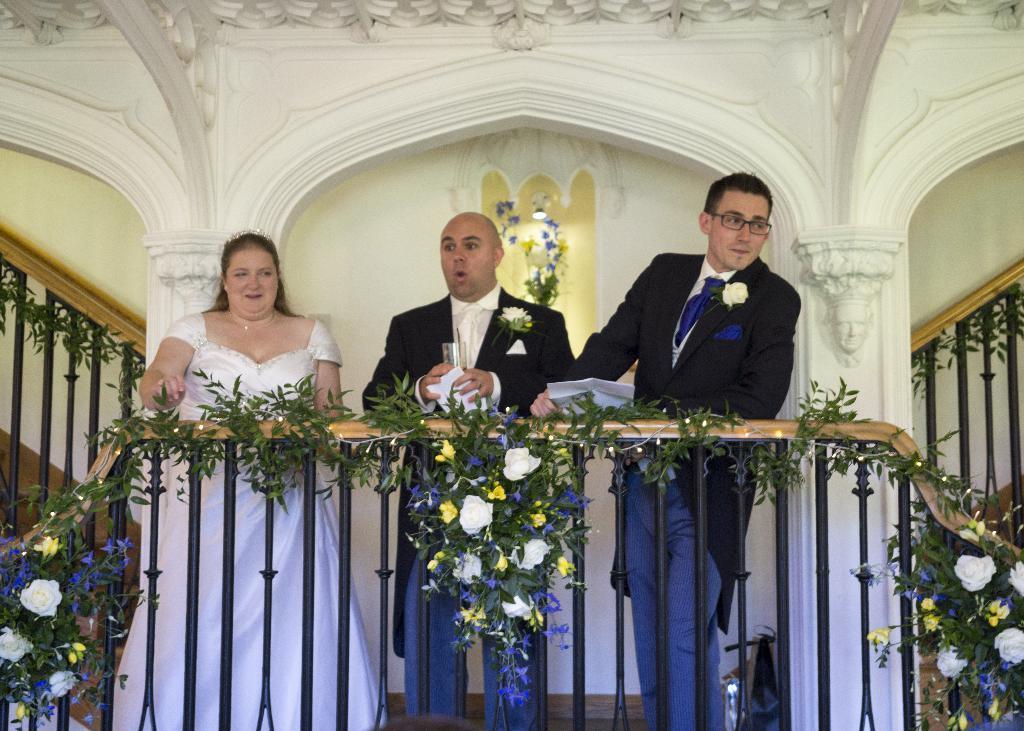Please provide a concise description of this image. In this picture, we see two men and a woman are standing. We see the man and the women are smiling. The man on the right side is holding the papers. Beside that, we see the man is holding the tissue papers and a glass. In front of them, we see the star railing which is decorated with the lights, artificial creepers and flower bouquets. Behind them, we see the pillars and a white wall. On either side of the picture, we see the stair railings. In the background, we see the flower case and a light. 